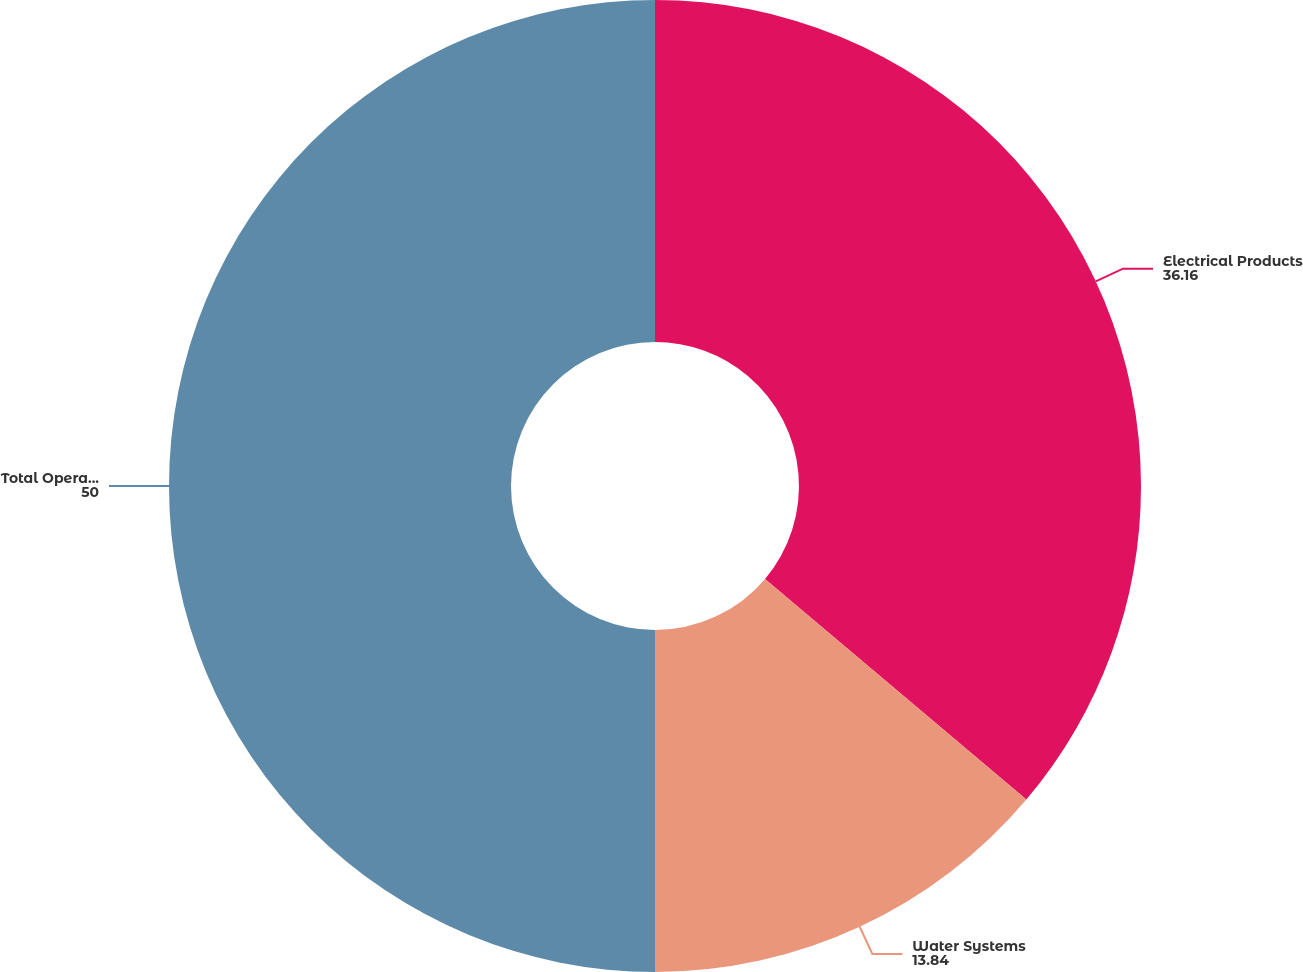<chart> <loc_0><loc_0><loc_500><loc_500><pie_chart><fcel>Electrical Products<fcel>Water Systems<fcel>Total Operations<nl><fcel>36.16%<fcel>13.84%<fcel>50.0%<nl></chart> 